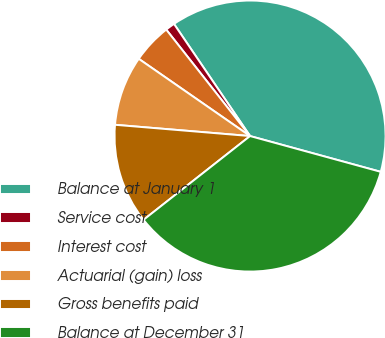<chart> <loc_0><loc_0><loc_500><loc_500><pie_chart><fcel>Balance at January 1<fcel>Service cost<fcel>Interest cost<fcel>Actuarial (gain) loss<fcel>Gross benefits paid<fcel>Balance at December 31<nl><fcel>38.74%<fcel>1.13%<fcel>4.73%<fcel>8.33%<fcel>11.93%<fcel>35.14%<nl></chart> 